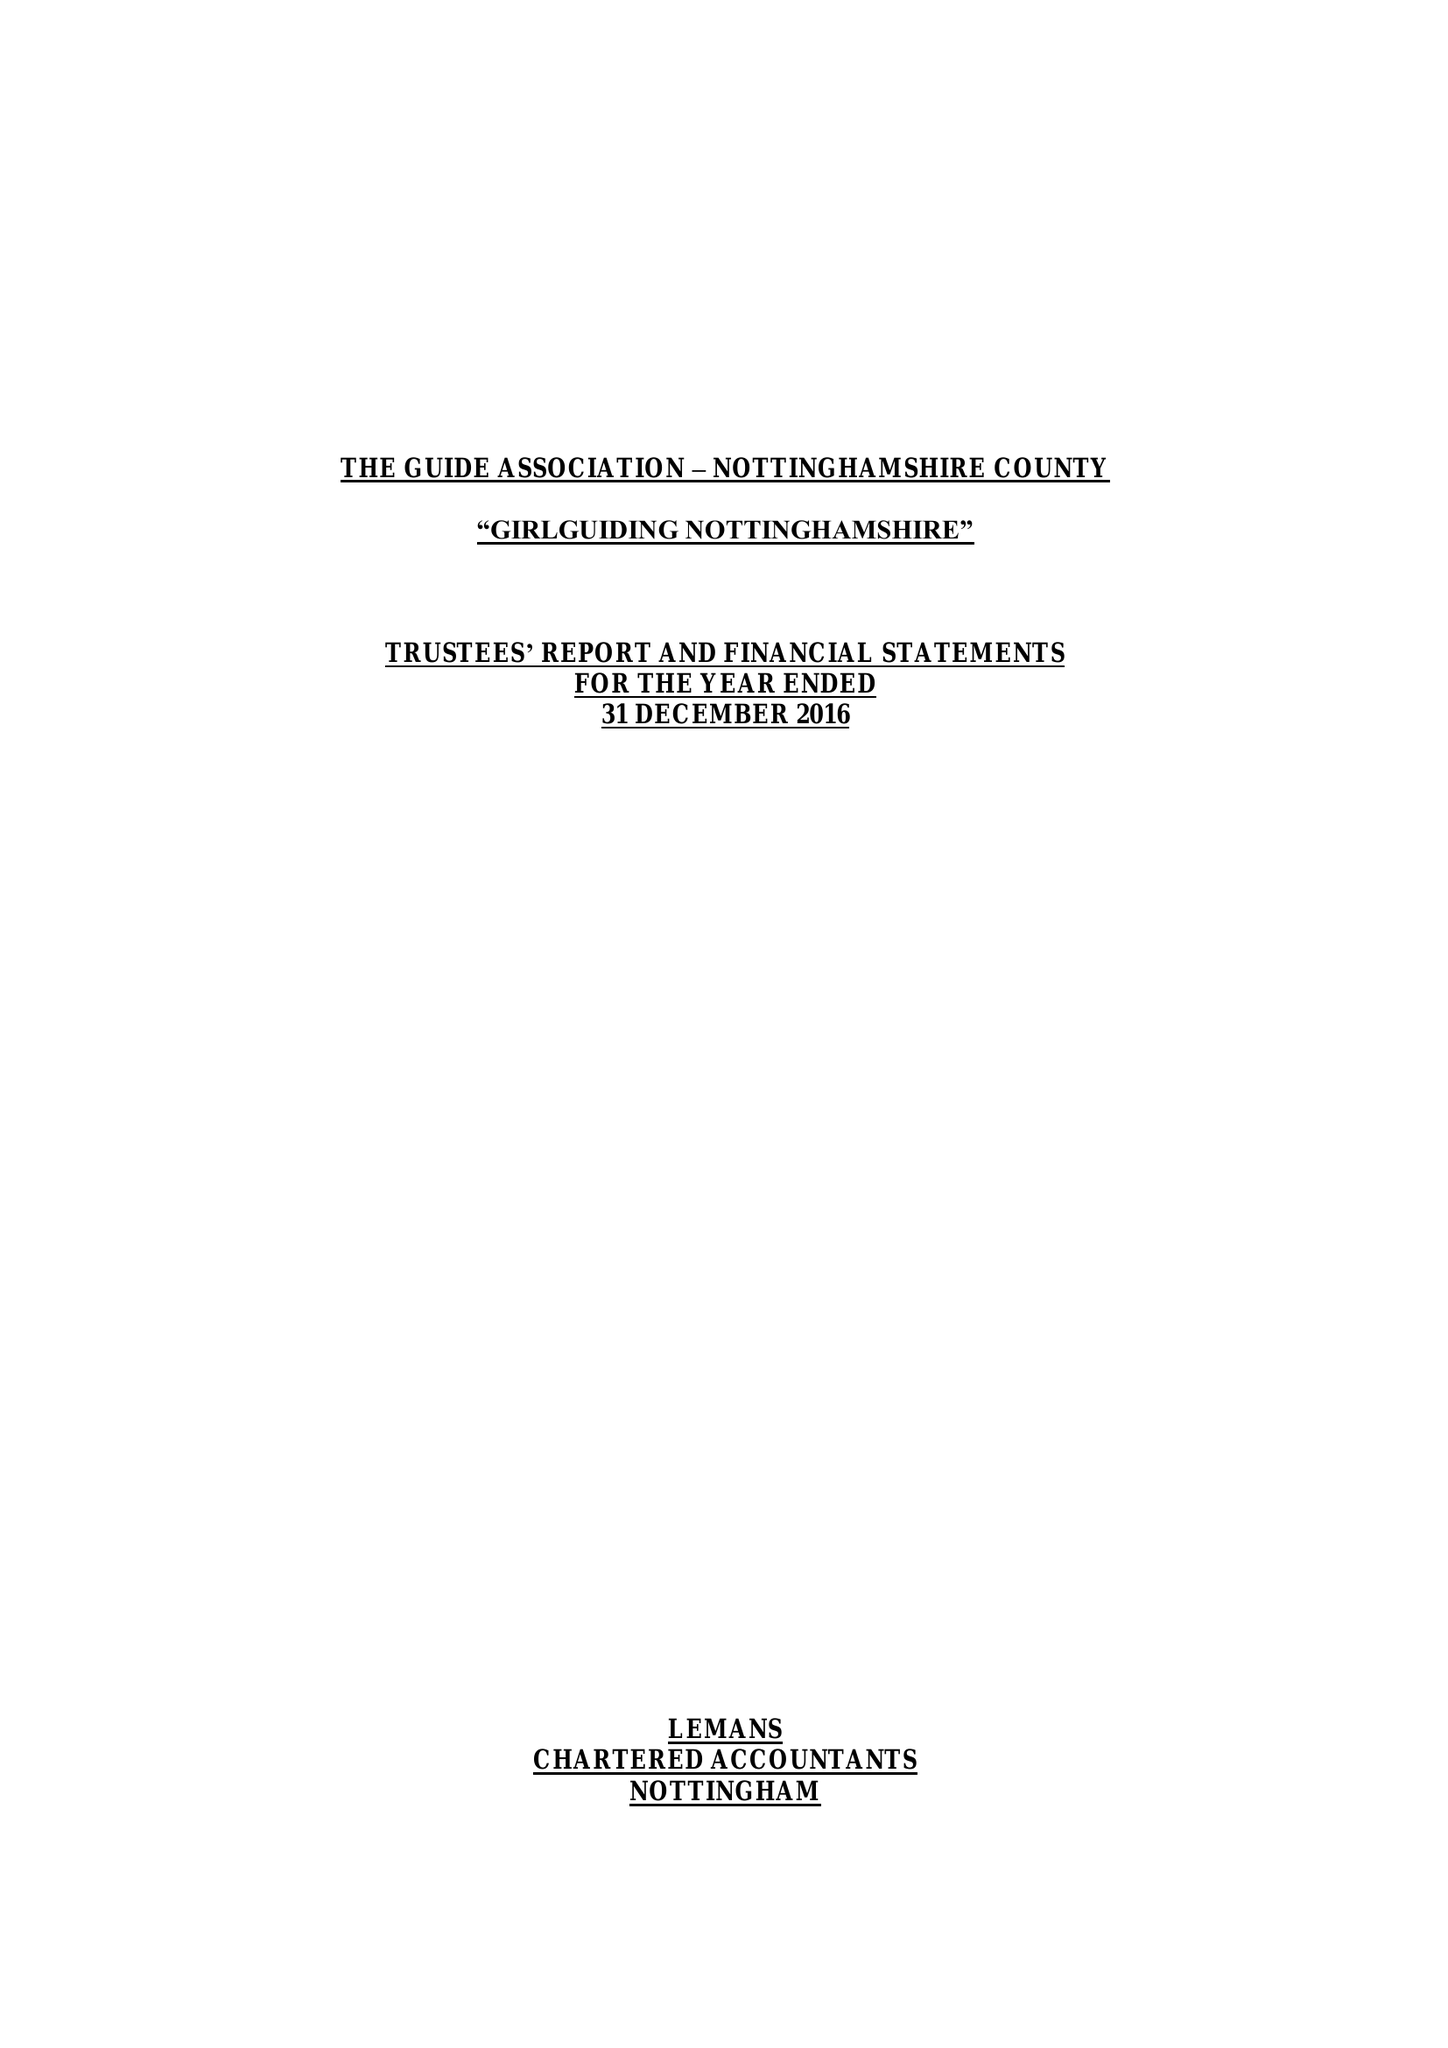What is the value for the address__postcode?
Answer the question using a single word or phrase. NG4 3DF 